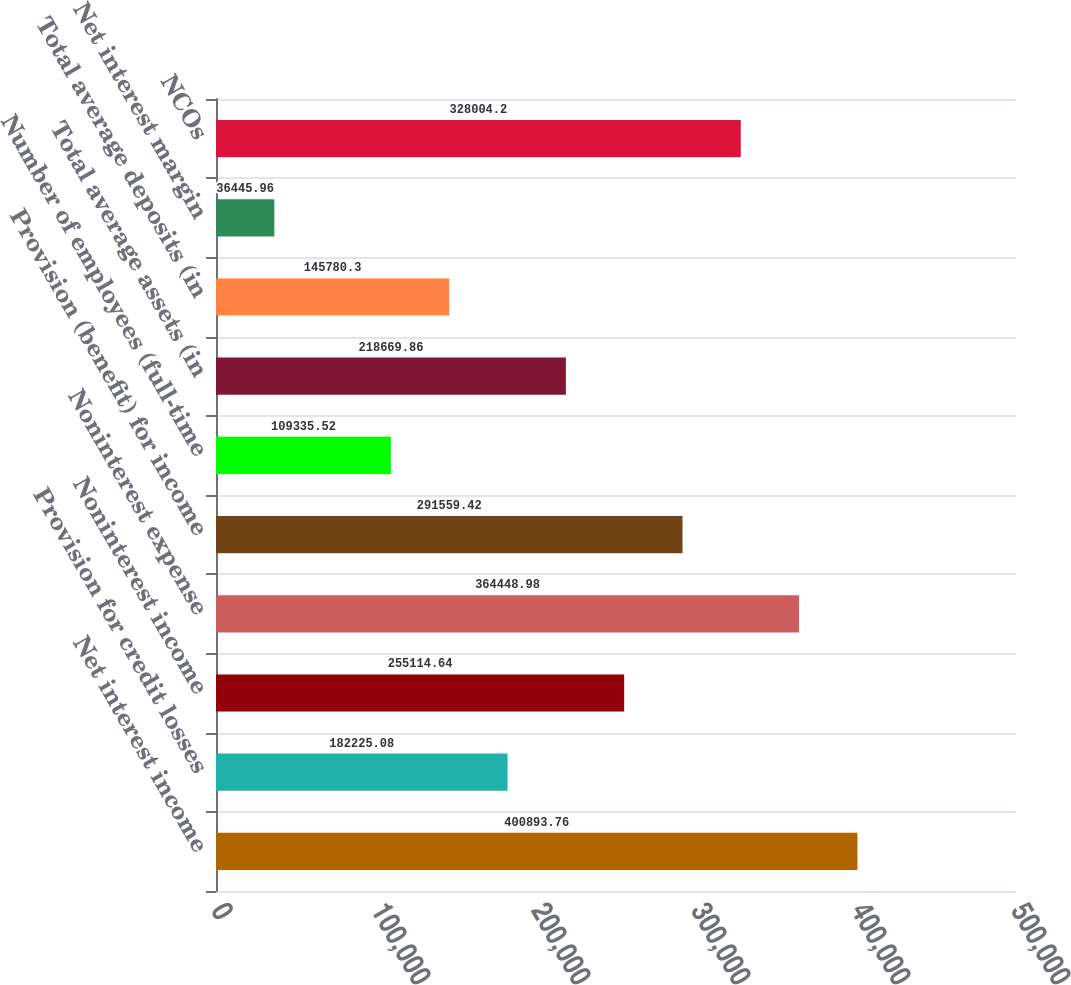Convert chart. <chart><loc_0><loc_0><loc_500><loc_500><bar_chart><fcel>Net interest income<fcel>Provision for credit losses<fcel>Noninterest income<fcel>Noninterest expense<fcel>Provision (benefit) for income<fcel>Number of employees (full-time<fcel>Total average assets (in<fcel>Total average deposits (in<fcel>Net interest margin<fcel>NCOs<nl><fcel>400894<fcel>182225<fcel>255115<fcel>364449<fcel>291559<fcel>109336<fcel>218670<fcel>145780<fcel>36446<fcel>328004<nl></chart> 